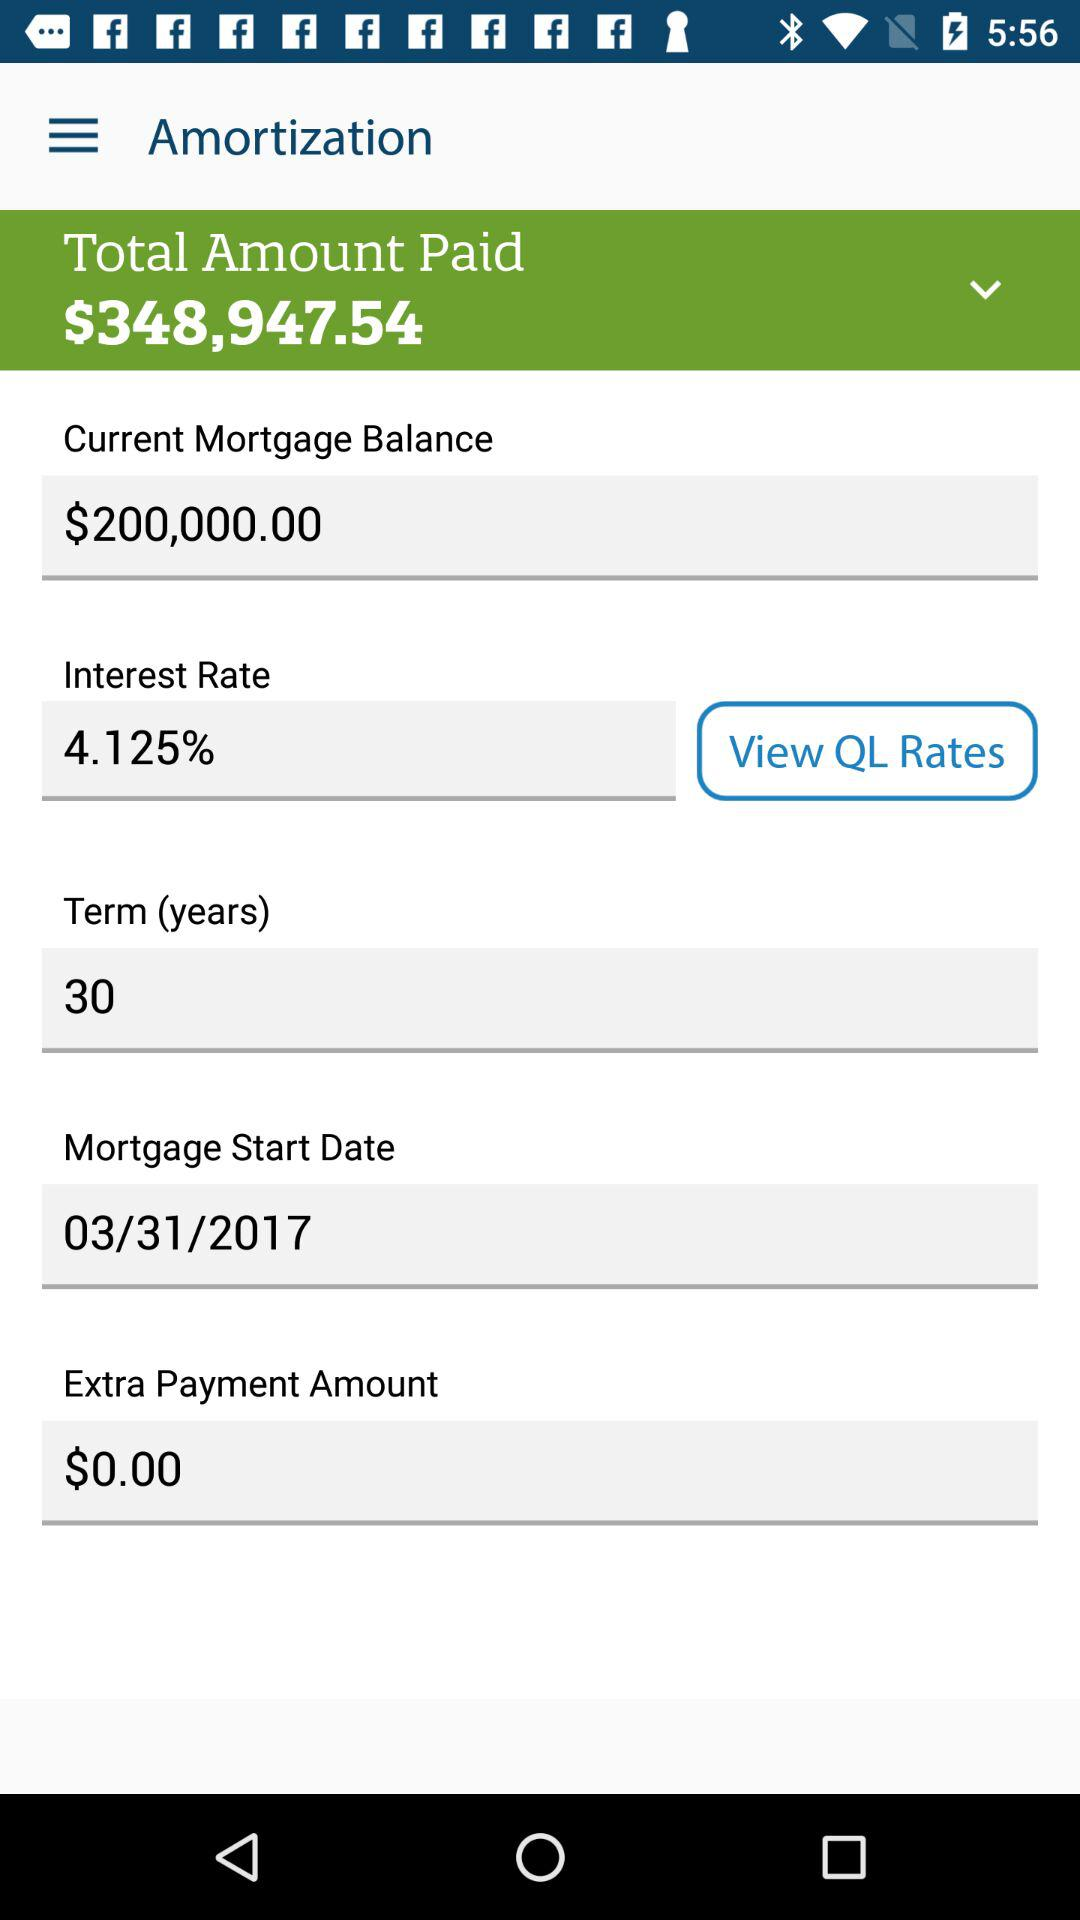What is the term? The term is 30 years. 